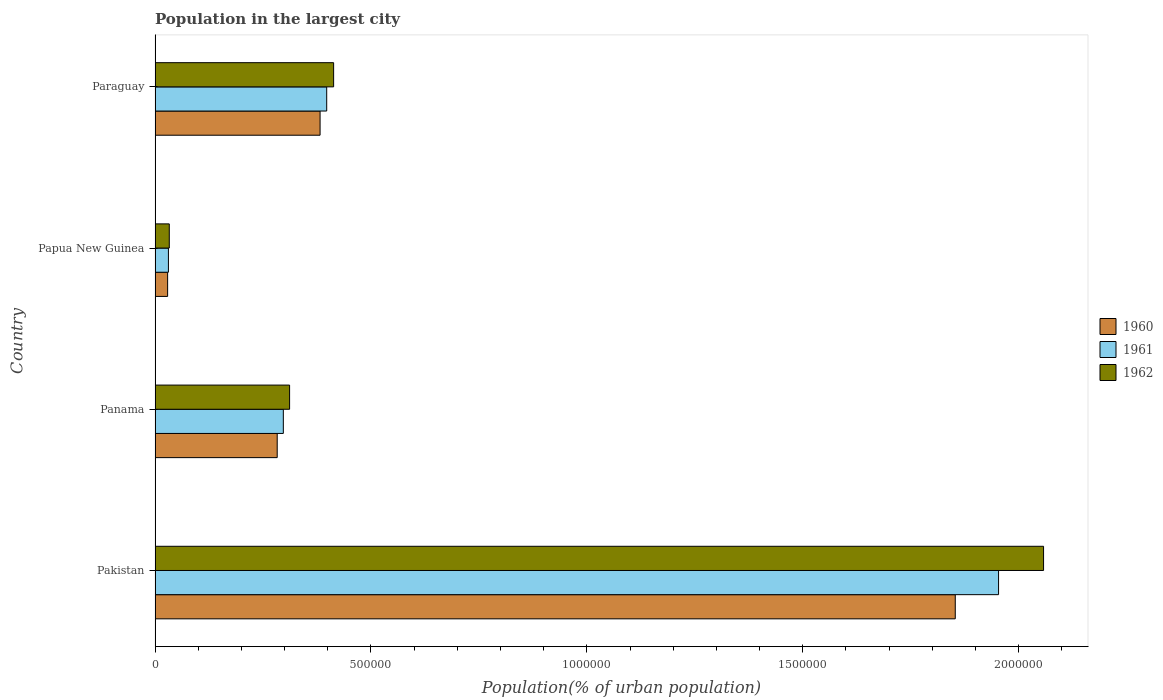How many groups of bars are there?
Keep it short and to the point. 4. Are the number of bars on each tick of the Y-axis equal?
Your response must be concise. Yes. How many bars are there on the 2nd tick from the top?
Make the answer very short. 3. How many bars are there on the 2nd tick from the bottom?
Provide a short and direct response. 3. What is the label of the 3rd group of bars from the top?
Give a very brief answer. Panama. In how many cases, is the number of bars for a given country not equal to the number of legend labels?
Provide a short and direct response. 0. What is the population in the largest city in 1962 in Papua New Guinea?
Offer a terse response. 3.29e+04. Across all countries, what is the maximum population in the largest city in 1960?
Make the answer very short. 1.85e+06. Across all countries, what is the minimum population in the largest city in 1962?
Offer a terse response. 3.29e+04. In which country was the population in the largest city in 1960 minimum?
Your response must be concise. Papua New Guinea. What is the total population in the largest city in 1962 in the graph?
Make the answer very short. 2.82e+06. What is the difference between the population in the largest city in 1960 in Papua New Guinea and that in Paraguay?
Provide a short and direct response. -3.53e+05. What is the difference between the population in the largest city in 1962 in Panama and the population in the largest city in 1961 in Paraguay?
Ensure brevity in your answer.  -8.60e+04. What is the average population in the largest city in 1962 per country?
Keep it short and to the point. 7.04e+05. What is the difference between the population in the largest city in 1961 and population in the largest city in 1962 in Paraguay?
Make the answer very short. -1.60e+04. In how many countries, is the population in the largest city in 1960 greater than 400000 %?
Keep it short and to the point. 1. What is the ratio of the population in the largest city in 1962 in Panama to that in Papua New Guinea?
Ensure brevity in your answer.  9.46. What is the difference between the highest and the second highest population in the largest city in 1961?
Ensure brevity in your answer.  1.56e+06. What is the difference between the highest and the lowest population in the largest city in 1962?
Keep it short and to the point. 2.02e+06. In how many countries, is the population in the largest city in 1960 greater than the average population in the largest city in 1960 taken over all countries?
Give a very brief answer. 1. Is the sum of the population in the largest city in 1961 in Pakistan and Paraguay greater than the maximum population in the largest city in 1960 across all countries?
Offer a terse response. Yes. What does the 2nd bar from the bottom in Panama represents?
Make the answer very short. 1961. Is it the case that in every country, the sum of the population in the largest city in 1962 and population in the largest city in 1961 is greater than the population in the largest city in 1960?
Make the answer very short. Yes. What is the difference between two consecutive major ticks on the X-axis?
Give a very brief answer. 5.00e+05. Are the values on the major ticks of X-axis written in scientific E-notation?
Your response must be concise. No. Does the graph contain any zero values?
Your answer should be very brief. No. Does the graph contain grids?
Give a very brief answer. No. Where does the legend appear in the graph?
Your answer should be compact. Center right. How are the legend labels stacked?
Offer a very short reply. Vertical. What is the title of the graph?
Your answer should be very brief. Population in the largest city. Does "1992" appear as one of the legend labels in the graph?
Your response must be concise. No. What is the label or title of the X-axis?
Offer a terse response. Population(% of urban population). What is the label or title of the Y-axis?
Offer a terse response. Country. What is the Population(% of urban population) of 1960 in Pakistan?
Your response must be concise. 1.85e+06. What is the Population(% of urban population) of 1961 in Pakistan?
Provide a short and direct response. 1.95e+06. What is the Population(% of urban population) of 1962 in Pakistan?
Provide a short and direct response. 2.06e+06. What is the Population(% of urban population) of 1960 in Panama?
Offer a terse response. 2.83e+05. What is the Population(% of urban population) in 1961 in Panama?
Keep it short and to the point. 2.97e+05. What is the Population(% of urban population) of 1962 in Panama?
Your answer should be compact. 3.12e+05. What is the Population(% of urban population) of 1960 in Papua New Guinea?
Your answer should be compact. 2.91e+04. What is the Population(% of urban population) in 1961 in Papua New Guinea?
Your response must be concise. 3.10e+04. What is the Population(% of urban population) of 1962 in Papua New Guinea?
Your response must be concise. 3.29e+04. What is the Population(% of urban population) in 1960 in Paraguay?
Your answer should be very brief. 3.82e+05. What is the Population(% of urban population) of 1961 in Paraguay?
Make the answer very short. 3.98e+05. What is the Population(% of urban population) in 1962 in Paraguay?
Offer a very short reply. 4.14e+05. Across all countries, what is the maximum Population(% of urban population) in 1960?
Give a very brief answer. 1.85e+06. Across all countries, what is the maximum Population(% of urban population) in 1961?
Your response must be concise. 1.95e+06. Across all countries, what is the maximum Population(% of urban population) in 1962?
Give a very brief answer. 2.06e+06. Across all countries, what is the minimum Population(% of urban population) of 1960?
Give a very brief answer. 2.91e+04. Across all countries, what is the minimum Population(% of urban population) of 1961?
Your answer should be very brief. 3.10e+04. Across all countries, what is the minimum Population(% of urban population) in 1962?
Your answer should be very brief. 3.29e+04. What is the total Population(% of urban population) of 1960 in the graph?
Give a very brief answer. 2.55e+06. What is the total Population(% of urban population) in 1961 in the graph?
Your answer should be very brief. 2.68e+06. What is the total Population(% of urban population) in 1962 in the graph?
Your response must be concise. 2.82e+06. What is the difference between the Population(% of urban population) in 1960 in Pakistan and that in Panama?
Your answer should be compact. 1.57e+06. What is the difference between the Population(% of urban population) of 1961 in Pakistan and that in Panama?
Provide a succinct answer. 1.66e+06. What is the difference between the Population(% of urban population) of 1962 in Pakistan and that in Panama?
Offer a terse response. 1.75e+06. What is the difference between the Population(% of urban population) of 1960 in Pakistan and that in Papua New Guinea?
Offer a very short reply. 1.82e+06. What is the difference between the Population(% of urban population) in 1961 in Pakistan and that in Papua New Guinea?
Offer a terse response. 1.92e+06. What is the difference between the Population(% of urban population) of 1962 in Pakistan and that in Papua New Guinea?
Provide a succinct answer. 2.02e+06. What is the difference between the Population(% of urban population) of 1960 in Pakistan and that in Paraguay?
Offer a terse response. 1.47e+06. What is the difference between the Population(% of urban population) in 1961 in Pakistan and that in Paraguay?
Your answer should be compact. 1.56e+06. What is the difference between the Population(% of urban population) in 1962 in Pakistan and that in Paraguay?
Offer a terse response. 1.64e+06. What is the difference between the Population(% of urban population) of 1960 in Panama and that in Papua New Guinea?
Provide a short and direct response. 2.54e+05. What is the difference between the Population(% of urban population) in 1961 in Panama and that in Papua New Guinea?
Offer a terse response. 2.66e+05. What is the difference between the Population(% of urban population) in 1962 in Panama and that in Papua New Guinea?
Your answer should be compact. 2.79e+05. What is the difference between the Population(% of urban population) of 1960 in Panama and that in Paraguay?
Your response must be concise. -9.93e+04. What is the difference between the Population(% of urban population) in 1961 in Panama and that in Paraguay?
Give a very brief answer. -1.00e+05. What is the difference between the Population(% of urban population) of 1962 in Panama and that in Paraguay?
Offer a terse response. -1.02e+05. What is the difference between the Population(% of urban population) in 1960 in Papua New Guinea and that in Paraguay?
Offer a terse response. -3.53e+05. What is the difference between the Population(% of urban population) of 1961 in Papua New Guinea and that in Paraguay?
Make the answer very short. -3.67e+05. What is the difference between the Population(% of urban population) in 1962 in Papua New Guinea and that in Paraguay?
Your response must be concise. -3.81e+05. What is the difference between the Population(% of urban population) of 1960 in Pakistan and the Population(% of urban population) of 1961 in Panama?
Offer a very short reply. 1.56e+06. What is the difference between the Population(% of urban population) in 1960 in Pakistan and the Population(% of urban population) in 1962 in Panama?
Keep it short and to the point. 1.54e+06. What is the difference between the Population(% of urban population) in 1961 in Pakistan and the Population(% of urban population) in 1962 in Panama?
Keep it short and to the point. 1.64e+06. What is the difference between the Population(% of urban population) of 1960 in Pakistan and the Population(% of urban population) of 1961 in Papua New Guinea?
Your answer should be compact. 1.82e+06. What is the difference between the Population(% of urban population) in 1960 in Pakistan and the Population(% of urban population) in 1962 in Papua New Guinea?
Keep it short and to the point. 1.82e+06. What is the difference between the Population(% of urban population) of 1961 in Pakistan and the Population(% of urban population) of 1962 in Papua New Guinea?
Your response must be concise. 1.92e+06. What is the difference between the Population(% of urban population) in 1960 in Pakistan and the Population(% of urban population) in 1961 in Paraguay?
Give a very brief answer. 1.46e+06. What is the difference between the Population(% of urban population) of 1960 in Pakistan and the Population(% of urban population) of 1962 in Paraguay?
Your answer should be compact. 1.44e+06. What is the difference between the Population(% of urban population) of 1961 in Pakistan and the Population(% of urban population) of 1962 in Paraguay?
Ensure brevity in your answer.  1.54e+06. What is the difference between the Population(% of urban population) of 1960 in Panama and the Population(% of urban population) of 1961 in Papua New Guinea?
Your answer should be very brief. 2.52e+05. What is the difference between the Population(% of urban population) of 1960 in Panama and the Population(% of urban population) of 1962 in Papua New Guinea?
Your answer should be very brief. 2.50e+05. What is the difference between the Population(% of urban population) in 1961 in Panama and the Population(% of urban population) in 1962 in Papua New Guinea?
Provide a short and direct response. 2.64e+05. What is the difference between the Population(% of urban population) in 1960 in Panama and the Population(% of urban population) in 1961 in Paraguay?
Keep it short and to the point. -1.15e+05. What is the difference between the Population(% of urban population) in 1960 in Panama and the Population(% of urban population) in 1962 in Paraguay?
Make the answer very short. -1.31e+05. What is the difference between the Population(% of urban population) in 1961 in Panama and the Population(% of urban population) in 1962 in Paraguay?
Keep it short and to the point. -1.16e+05. What is the difference between the Population(% of urban population) of 1960 in Papua New Guinea and the Population(% of urban population) of 1961 in Paraguay?
Make the answer very short. -3.68e+05. What is the difference between the Population(% of urban population) of 1960 in Papua New Guinea and the Population(% of urban population) of 1962 in Paraguay?
Offer a very short reply. -3.84e+05. What is the difference between the Population(% of urban population) in 1961 in Papua New Guinea and the Population(% of urban population) in 1962 in Paraguay?
Ensure brevity in your answer.  -3.83e+05. What is the average Population(% of urban population) in 1960 per country?
Your answer should be very brief. 6.37e+05. What is the average Population(% of urban population) of 1961 per country?
Keep it short and to the point. 6.70e+05. What is the average Population(% of urban population) in 1962 per country?
Provide a short and direct response. 7.04e+05. What is the difference between the Population(% of urban population) of 1960 and Population(% of urban population) of 1961 in Pakistan?
Your response must be concise. -1.00e+05. What is the difference between the Population(% of urban population) of 1960 and Population(% of urban population) of 1962 in Pakistan?
Your response must be concise. -2.05e+05. What is the difference between the Population(% of urban population) in 1961 and Population(% of urban population) in 1962 in Pakistan?
Make the answer very short. -1.04e+05. What is the difference between the Population(% of urban population) of 1960 and Population(% of urban population) of 1961 in Panama?
Keep it short and to the point. -1.42e+04. What is the difference between the Population(% of urban population) of 1960 and Population(% of urban population) of 1962 in Panama?
Keep it short and to the point. -2.87e+04. What is the difference between the Population(% of urban population) of 1961 and Population(% of urban population) of 1962 in Panama?
Make the answer very short. -1.45e+04. What is the difference between the Population(% of urban population) of 1960 and Population(% of urban population) of 1961 in Papua New Guinea?
Provide a succinct answer. -1850. What is the difference between the Population(% of urban population) in 1960 and Population(% of urban population) in 1962 in Papua New Guinea?
Provide a short and direct response. -3820. What is the difference between the Population(% of urban population) in 1961 and Population(% of urban population) in 1962 in Papua New Guinea?
Provide a succinct answer. -1970. What is the difference between the Population(% of urban population) in 1960 and Population(% of urban population) in 1961 in Paraguay?
Keep it short and to the point. -1.54e+04. What is the difference between the Population(% of urban population) in 1960 and Population(% of urban population) in 1962 in Paraguay?
Your answer should be compact. -3.14e+04. What is the difference between the Population(% of urban population) of 1961 and Population(% of urban population) of 1962 in Paraguay?
Give a very brief answer. -1.60e+04. What is the ratio of the Population(% of urban population) of 1960 in Pakistan to that in Panama?
Give a very brief answer. 6.55. What is the ratio of the Population(% of urban population) in 1961 in Pakistan to that in Panama?
Your answer should be very brief. 6.58. What is the ratio of the Population(% of urban population) in 1962 in Pakistan to that in Panama?
Ensure brevity in your answer.  6.6. What is the ratio of the Population(% of urban population) of 1960 in Pakistan to that in Papua New Guinea?
Keep it short and to the point. 63.68. What is the ratio of the Population(% of urban population) of 1961 in Pakistan to that in Papua New Guinea?
Ensure brevity in your answer.  63.12. What is the ratio of the Population(% of urban population) of 1962 in Pakistan to that in Papua New Guinea?
Offer a terse response. 62.5. What is the ratio of the Population(% of urban population) of 1960 in Pakistan to that in Paraguay?
Keep it short and to the point. 4.85. What is the ratio of the Population(% of urban population) in 1961 in Pakistan to that in Paraguay?
Provide a succinct answer. 4.91. What is the ratio of the Population(% of urban population) in 1962 in Pakistan to that in Paraguay?
Your response must be concise. 4.98. What is the ratio of the Population(% of urban population) in 1960 in Panama to that in Papua New Guinea?
Your answer should be very brief. 9.72. What is the ratio of the Population(% of urban population) of 1961 in Panama to that in Papua New Guinea?
Your response must be concise. 9.6. What is the ratio of the Population(% of urban population) in 1962 in Panama to that in Papua New Guinea?
Offer a very short reply. 9.46. What is the ratio of the Population(% of urban population) in 1960 in Panama to that in Paraguay?
Provide a succinct answer. 0.74. What is the ratio of the Population(% of urban population) in 1961 in Panama to that in Paraguay?
Your answer should be compact. 0.75. What is the ratio of the Population(% of urban population) in 1962 in Panama to that in Paraguay?
Offer a very short reply. 0.75. What is the ratio of the Population(% of urban population) in 1960 in Papua New Guinea to that in Paraguay?
Your answer should be compact. 0.08. What is the ratio of the Population(% of urban population) in 1961 in Papua New Guinea to that in Paraguay?
Offer a terse response. 0.08. What is the ratio of the Population(% of urban population) in 1962 in Papua New Guinea to that in Paraguay?
Your response must be concise. 0.08. What is the difference between the highest and the second highest Population(% of urban population) of 1960?
Provide a short and direct response. 1.47e+06. What is the difference between the highest and the second highest Population(% of urban population) in 1961?
Your response must be concise. 1.56e+06. What is the difference between the highest and the second highest Population(% of urban population) of 1962?
Give a very brief answer. 1.64e+06. What is the difference between the highest and the lowest Population(% of urban population) of 1960?
Provide a succinct answer. 1.82e+06. What is the difference between the highest and the lowest Population(% of urban population) in 1961?
Offer a terse response. 1.92e+06. What is the difference between the highest and the lowest Population(% of urban population) in 1962?
Offer a terse response. 2.02e+06. 